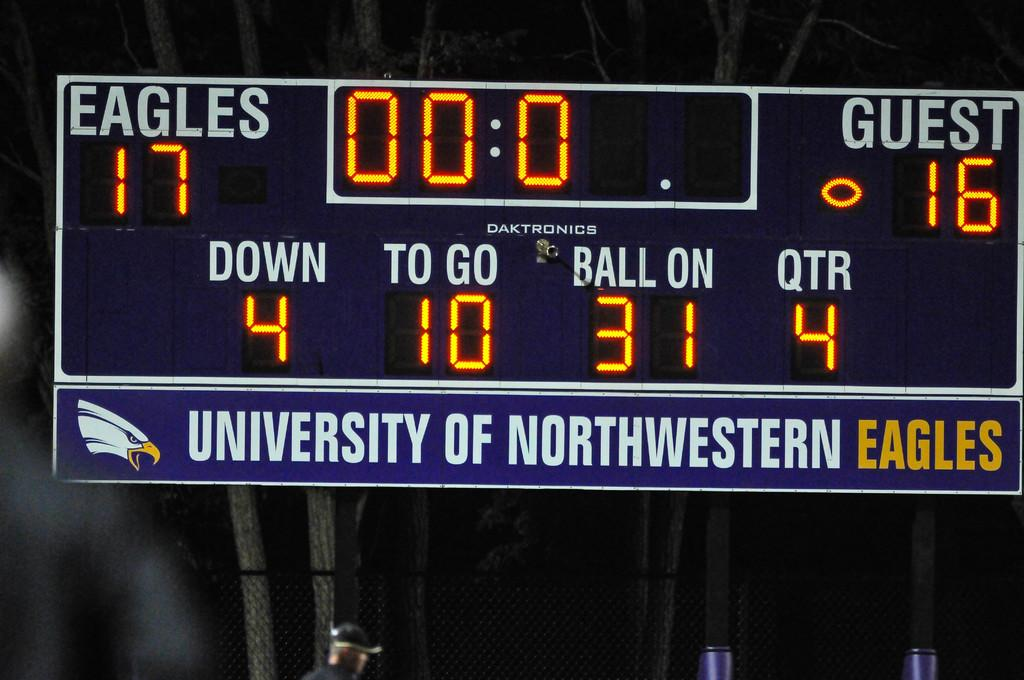<image>
Summarize the visual content of the image. A scoreboard showing the University of Northwestern Eagles at leading 17-16 in the fourth quarter. 